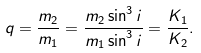<formula> <loc_0><loc_0><loc_500><loc_500>q = \frac { m _ { 2 } } { m _ { 1 } } = \frac { m _ { 2 } \sin ^ { 3 } i } { m _ { 1 } \sin ^ { 3 } i } = \frac { K _ { 1 } } { K _ { 2 } } .</formula> 